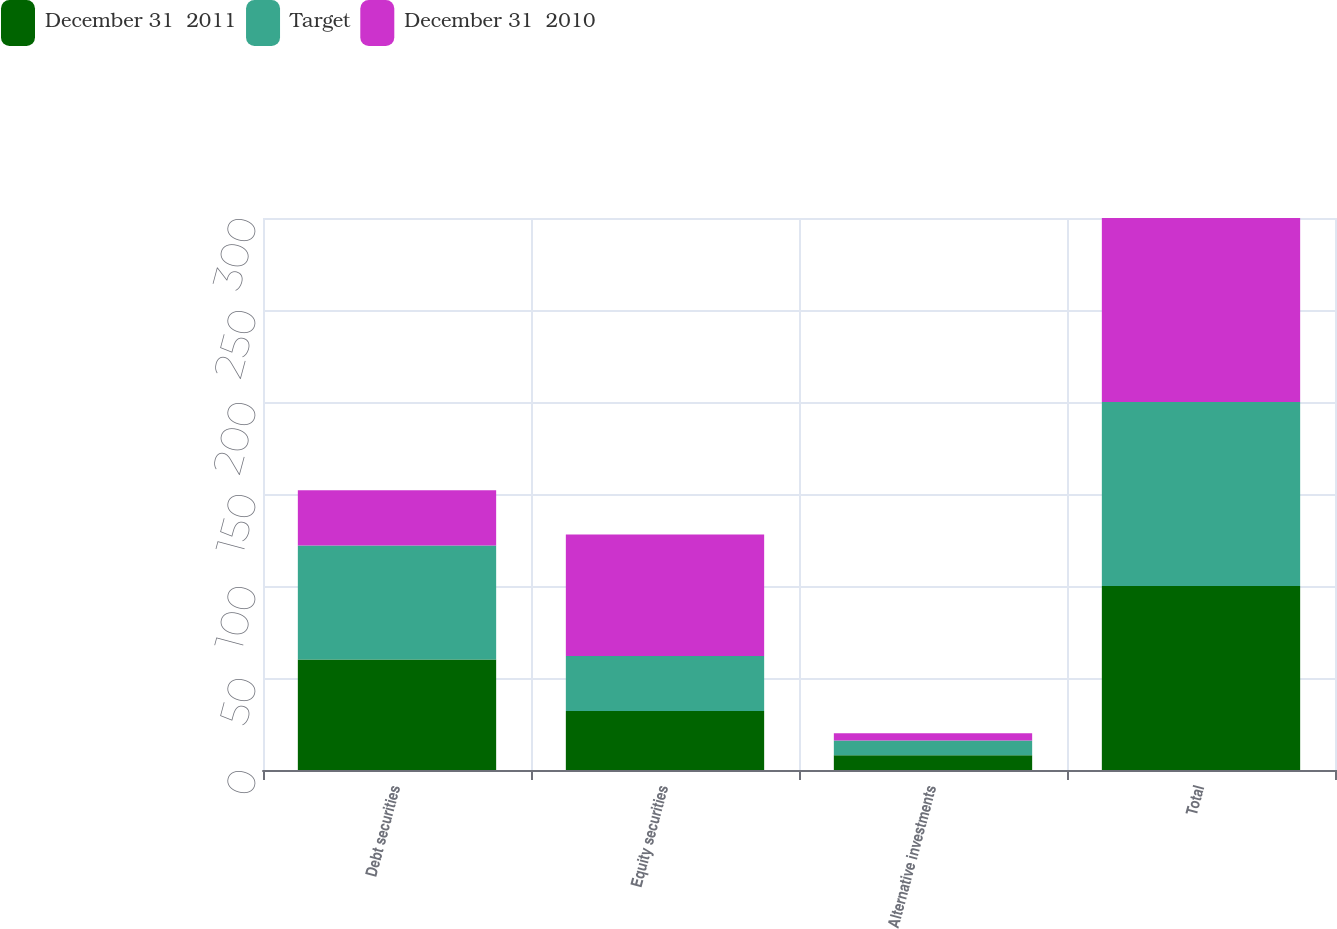<chart> <loc_0><loc_0><loc_500><loc_500><stacked_bar_chart><ecel><fcel>Debt securities<fcel>Equity securities<fcel>Alternative investments<fcel>Total<nl><fcel>December 31  2011<fcel>60<fcel>32<fcel>8<fcel>100<nl><fcel>Target<fcel>62<fcel>30<fcel>8<fcel>100<nl><fcel>December 31  2010<fcel>30<fcel>66<fcel>4<fcel>100<nl></chart> 